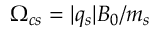<formula> <loc_0><loc_0><loc_500><loc_500>\Omega _ { c s } = | q { _ { s } } | B _ { 0 } / m _ { s }</formula> 